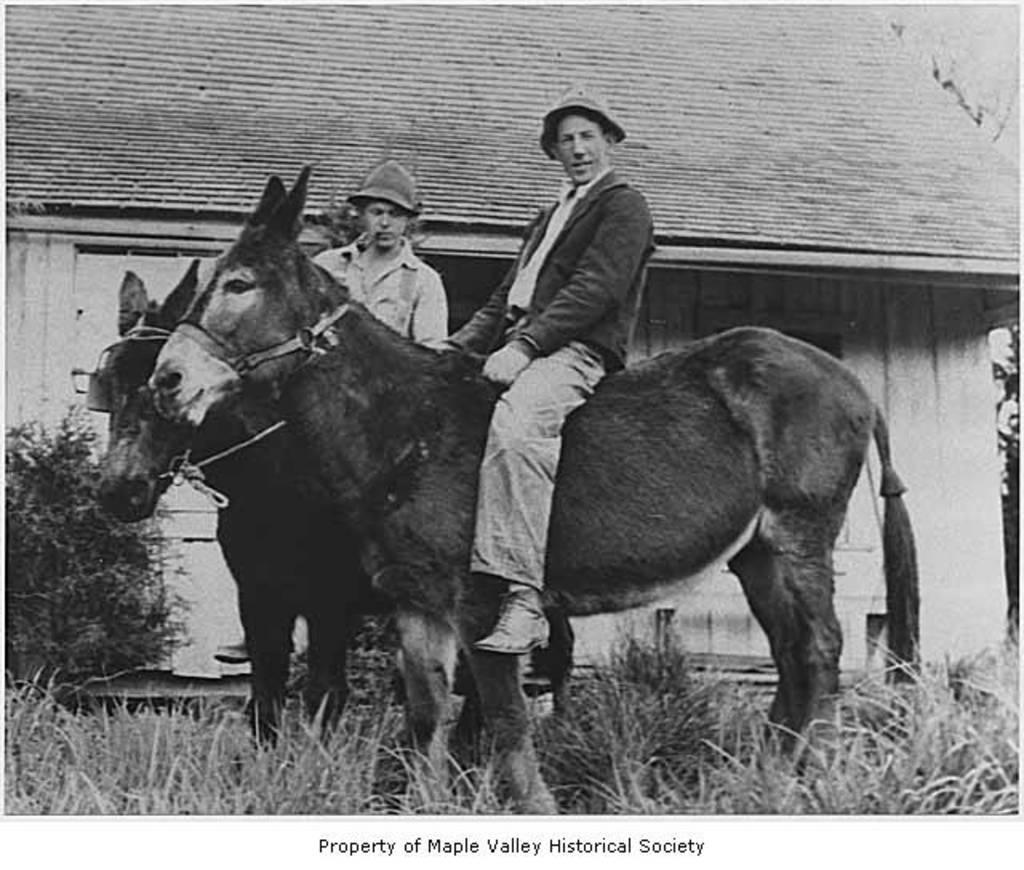How would you summarize this image in a sentence or two? In this image I can see the black and white picture. I can see two persons wearing hats are sitting on donkeys which are standing on the ground. I can see some grass, a plant and the house. 